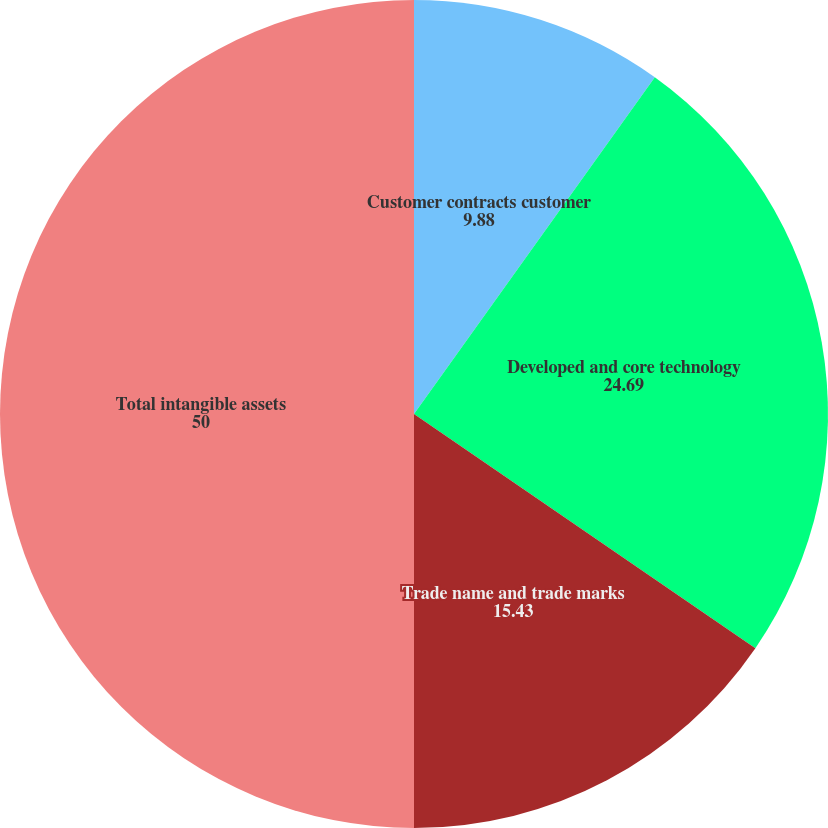Convert chart. <chart><loc_0><loc_0><loc_500><loc_500><pie_chart><fcel>Customer contracts customer<fcel>Developed and core technology<fcel>Trade name and trade marks<fcel>Total intangible assets<nl><fcel>9.88%<fcel>24.69%<fcel>15.43%<fcel>50.0%<nl></chart> 